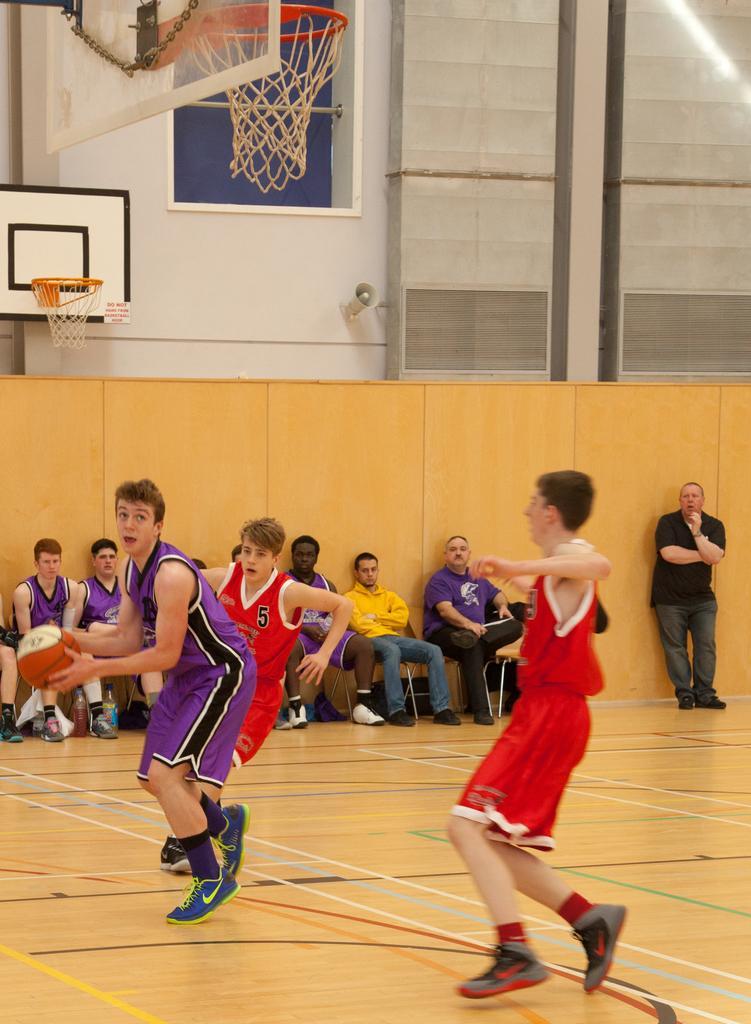How would you summarize this image in a sentence or two? There are three persons playing basketball. And the person on the left is holding a ball. In the back some people are sitting. And a person on the right is standing. Behind them there is a wall. Behind that there is another wall. On that there is a board with basketball net. On the top left corner there is a board and a basketball net. 